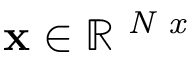Convert formula to latex. <formula><loc_0><loc_0><loc_500><loc_500>x \in \mathbb { R } ^ { N x }</formula> 